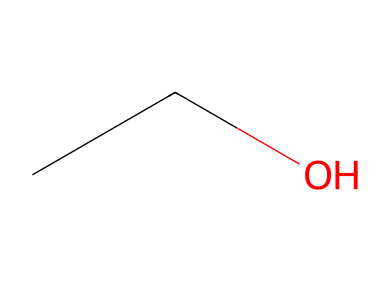What is the name of this chemical? The chemical structure represented by the SMILES notation "CCO" corresponds to ethanol, which is commonly used as an alcohol in hand sanitizers.
Answer: ethanol How many carbon atoms are in this molecule? The SMILES notation "CCO" shows that there are two "C" characters before the "O," indicating there are two carbon atoms in the structure.
Answer: 2 What functional group is present in this molecule? The presence of the "O" in the SMILES notation "CCO" indicates that there is a hydroxyl group (-OH) present, which is characteristic of alcohols like ethanol.
Answer: hydroxyl group What is the total number of hydrogen atoms in this molecule? In the ethanol structure "CCO," each carbon atom can form four bonds. With two carbon atoms and one hydroxyl group, the total number of hydrogen atoms is calculated as six, as each carbon bonds fully with hydrogen (C2H6O).
Answer: 6 Is this molecule a saturated hydrocarbon? Ethanol has a hydrocarbon backbone with all single bonds (the two Cs are connected by a single bond, and each is connected to Hs), which means it is saturated; however, since it contains an -OH group, it is no longer a pure hydrocarbon but rather an alcohol.
Answer: no What type of isomerism can ethanol exhibit? Ethanol can exhibit positional isomerism because if the hydroxyl group were to shift position within the molecule, different isomers (like dimethyl ether) could be formed from the same molecular formula.
Answer: positional isomerism 